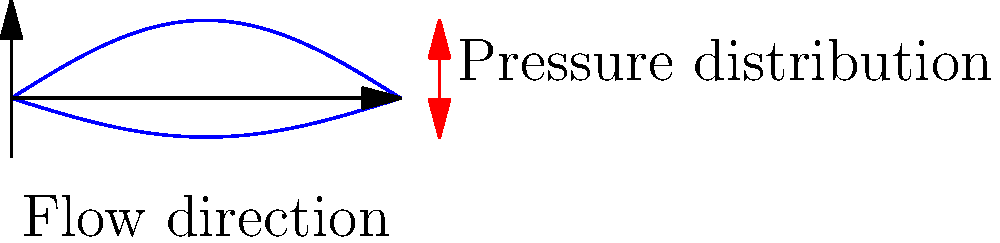Given the pressure distribution around an airfoil cross-section as shown in the figure, where red arrows indicate higher pressure, how does this relate to the generation of lift? Express your answer in terms of the pressure difference between the upper and lower surfaces and its effect on the net force. To understand how the pressure distribution relates to lift generation, let's break it down step-by-step:

1. Pressure difference:
   The figure shows a higher pressure (indicated by longer red arrows) on the lower surface of the airfoil compared to the upper surface.

2. Bernoulli's principle:
   This pressure difference is explained by Bernoulli's principle, which states that in a steady flow, an increase in fluid velocity occurs simultaneously with a decrease in pressure.

3. Airfoil shape:
   The curved shape of the airfoil causes the air to move faster over the upper surface than the lower surface.

4. Resulting pressures:
   As a result, the pressure on the upper surface is lower than on the lower surface.

5. Net force:
   The pressure difference creates a net force perpendicular to the flow direction.

6. Lift component:
   The vertical component of this net force is what we call lift.

7. Quantum mechanics connection:
   In quantum field theory, lift can be interpreted as a macroscopic manifestation of quantum interactions between air molecules and the airfoil surface, which could be represented in high-dimensional Hilbert spaces.

8. Mathematical representation:
   The lift force $F_L$ can be expressed as:
   
   $$F_L = \int_A (p_l - p_u) dA$$
   
   where $p_l$ and $p_u$ are the pressures on the lower and upper surfaces respectively, and $A$ is the wing area.

9. Visualization challenge:
   Representing this phenomenon in higher dimensions could involve tensor network states or quantum circuit diagrams to capture the quantum mechanical aspects of fluid-surface interactions.
Answer: The pressure difference between lower and upper surfaces creates a net upward force (lift). 